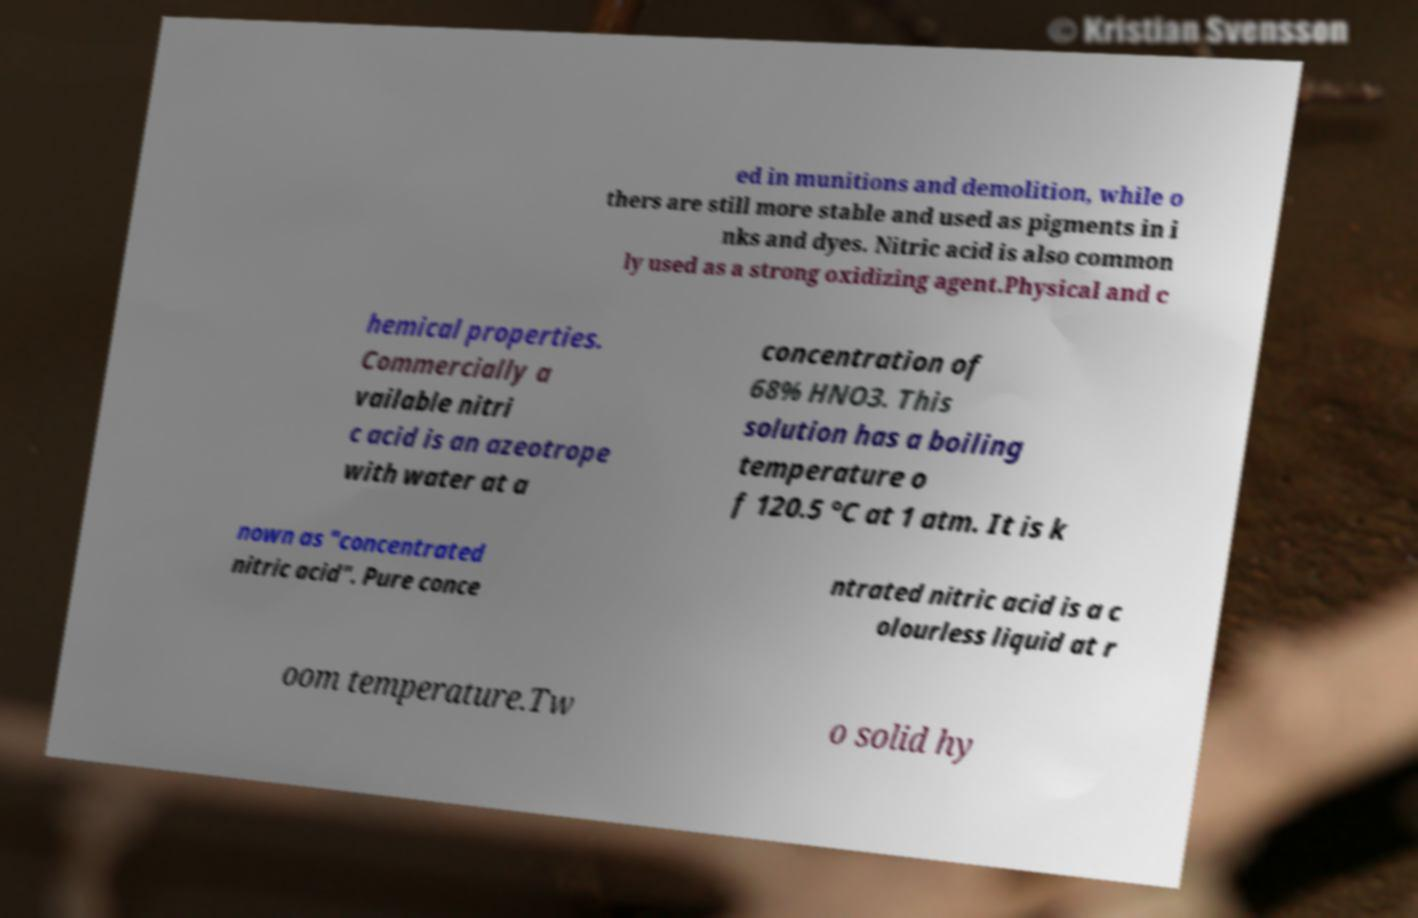For documentation purposes, I need the text within this image transcribed. Could you provide that? ed in munitions and demolition, while o thers are still more stable and used as pigments in i nks and dyes. Nitric acid is also common ly used as a strong oxidizing agent.Physical and c hemical properties. Commercially a vailable nitri c acid is an azeotrope with water at a concentration of 68% HNO3. This solution has a boiling temperature o f 120.5 °C at 1 atm. It is k nown as "concentrated nitric acid". Pure conce ntrated nitric acid is a c olourless liquid at r oom temperature.Tw o solid hy 